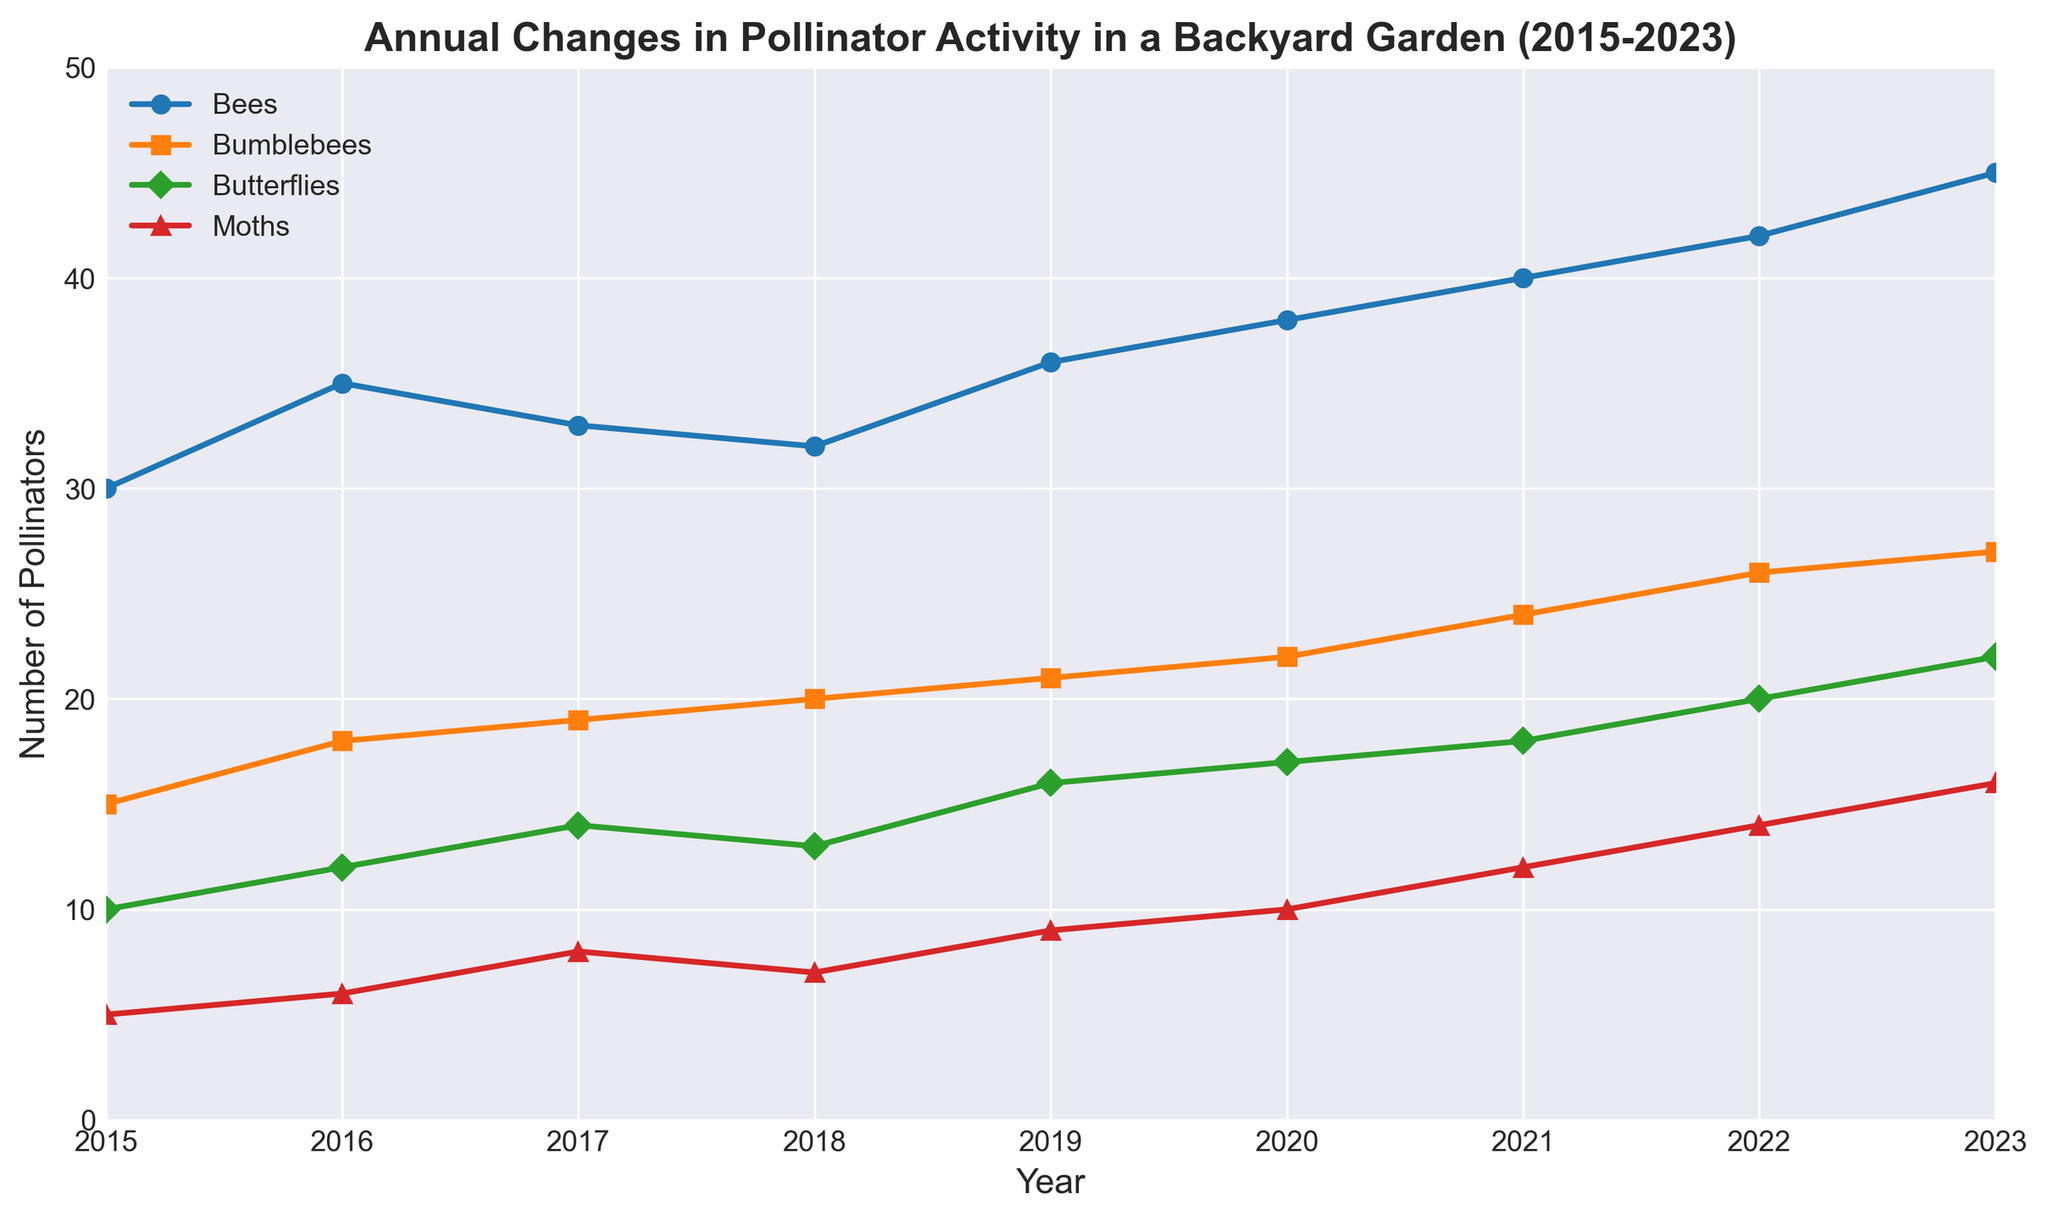Which pollinator saw the largest increase in numbers from 2015 to 2023? To find this, subtract the 2015 number from the 2023 number for each pollinator: Bees (45-30=15), Bumblebees (27-15=12), Butterflies (22-10=12), Moths (16-5=11). Bees had the largest increase.
Answer: Bees How many more butterflies than moths were there in 2023? Subtract the number of moths from the number of butterflies in 2023: 22 - 16 = 6.
Answer: 6 What is the average number of bees recorded from 2015 to 2023? Sum the number of bees for each year (30 + 35 + 33 + 32 + 36 + 38 + 40 + 42 + 45 = 331) and then divide by the number of years (9). The average is 331 / 9 ≈ 36.78.
Answer: 36.78 Comparing 2019 and 2022, which pollinator saw the greatest increase in activity? For each pollinator, subtract the 2019 number from the 2022 number: Bees (42-36=6), Bumblebees (26-21=5), Butterflies (20-16=4), Moths (14-9=5). Bees saw the greatest increase.
Answer: Bees In which year did bumblebee activity surpass 20 individuals? From the plot, the number of bumblebees surpasses 20 in 2018 and continues to increase each year after.
Answer: 2018 Were there any years when the number of butterflies decreased from the previous year? Observing the plot, there are no years where the number of butterflies decreased; they either increased or remained stable each year.
Answer: No What is the total number of pollinators recorded in 2020? Sum the number of each type of pollinator in 2020: Bees (38), Bumblebees (22), Butterflies (17), Moths (10). Total is 38 + 22 + 17 + 10 = 87.
Answer: 87 What color represents moths in the plot, and how did their numbers change from 2015 to 2017? Moths are represented by red colored lines and markers. From 2015 (5) to 2017 (8), their numbers increased by 3.
Answer: Red; increased by 3 Which year had the highest total number of pollinators? Sum the number of each type of pollinator for each year and find the year with the highest sum. The highest total is in 2023: Bees (45), Bumblebees (27), Butterflies (22), Moths (16). Total is 45 + 27 + 22 + 16 = 110.
Answer: 2023 Between 2017 and 2018, did the butterfly population increase or decrease? By how much? From the plot, the population in 2017 is 14 and in 2018 is 13. The butterfly population decreased. The decrease is 14 - 13 = 1.
Answer: Decrease by 1 